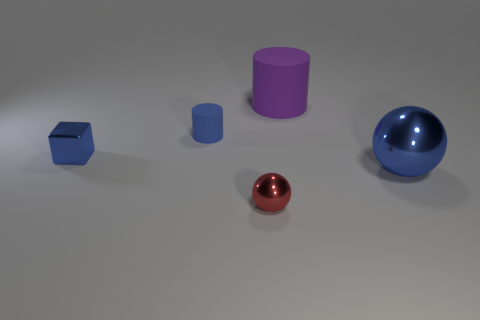There is another purple matte object that is the same shape as the tiny matte thing; what size is it? large 